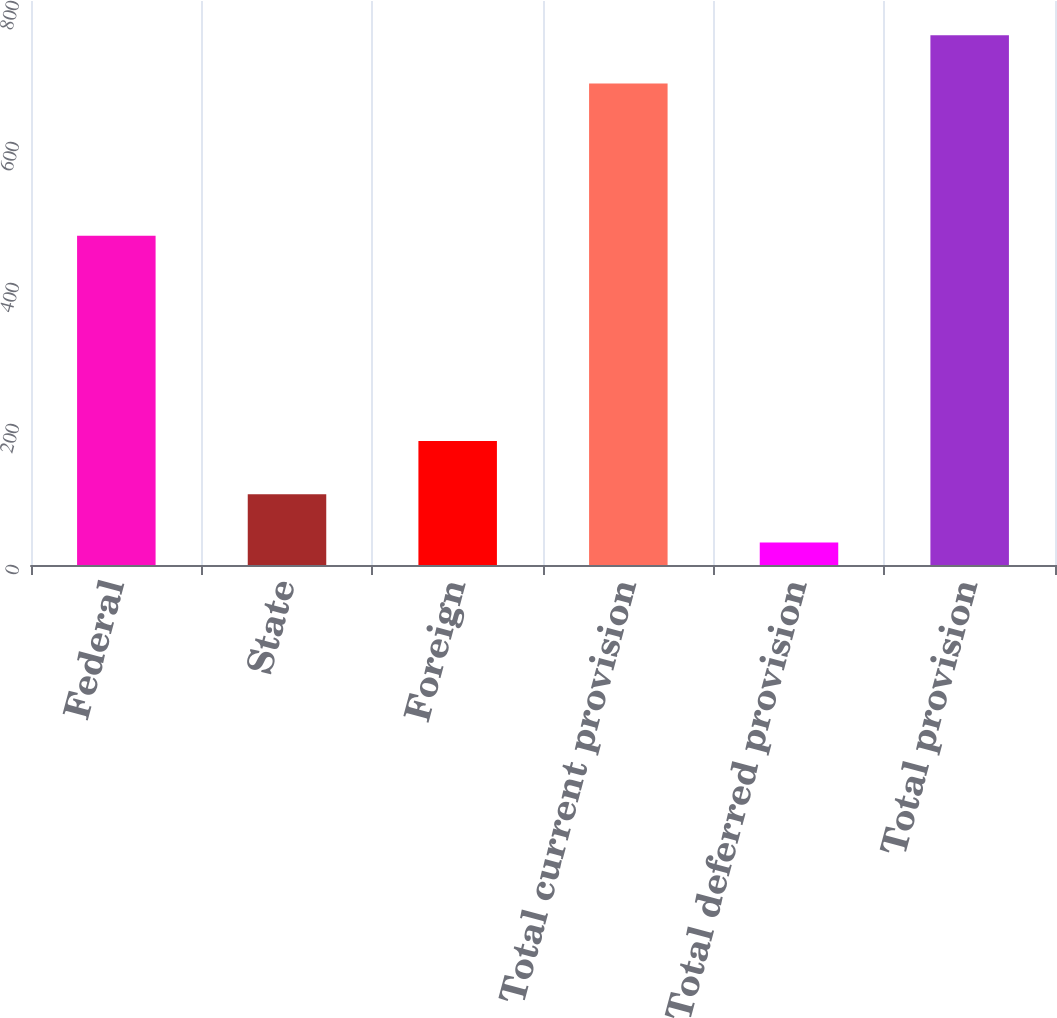Convert chart. <chart><loc_0><loc_0><loc_500><loc_500><bar_chart><fcel>Federal<fcel>State<fcel>Foreign<fcel>Total current provision<fcel>Total deferred provision<fcel>Total provision<nl><fcel>467<fcel>100.3<fcel>176<fcel>683<fcel>32<fcel>751.3<nl></chart> 